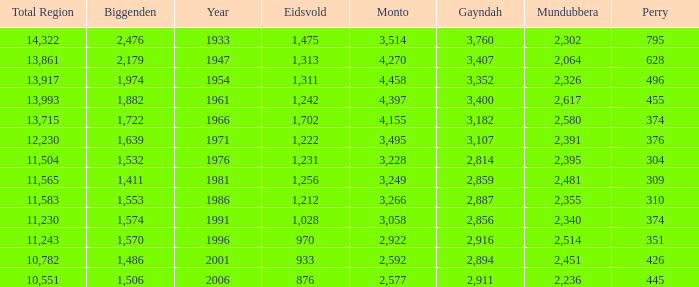Which is the year with Mundubbera being smaller than 2,395, and Biggenden smaller than 1,506? None. 